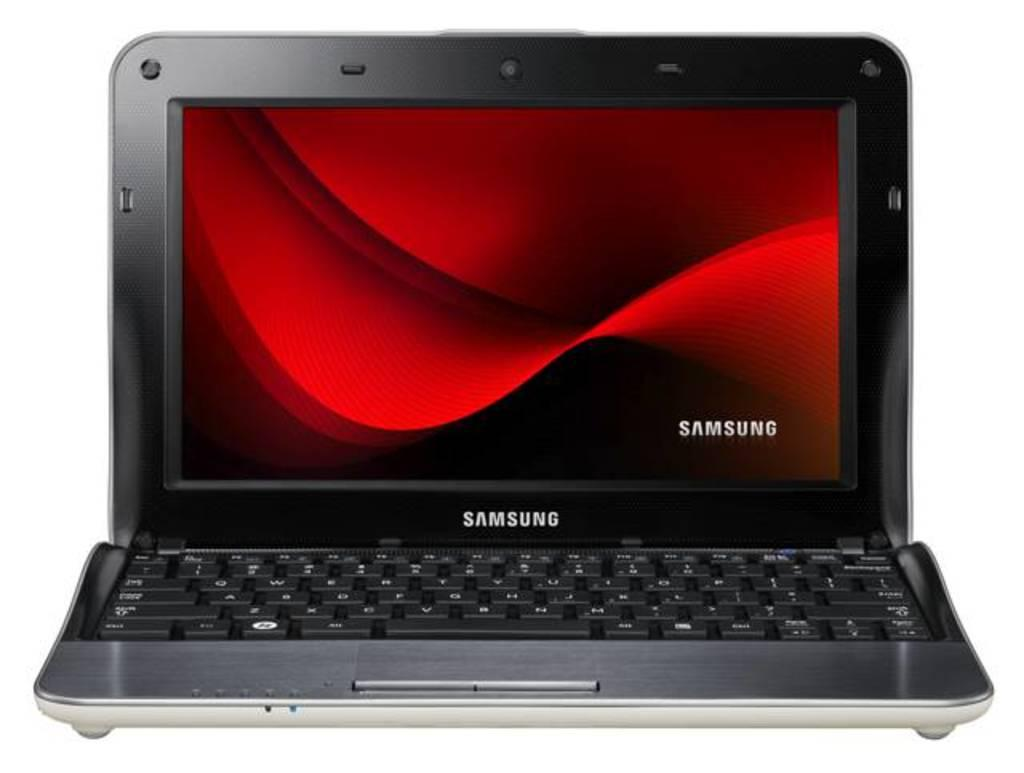Provide a one-sentence caption for the provided image. A Samsung laptop is open with a red screensaver. 